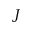Convert formula to latex. <formula><loc_0><loc_0><loc_500><loc_500>J</formula> 